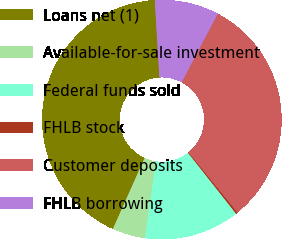Convert chart to OTSL. <chart><loc_0><loc_0><loc_500><loc_500><pie_chart><fcel>Loans net (1)<fcel>Available-for-sale investment<fcel>Federal funds sold<fcel>FHLB stock<fcel>Customer deposits<fcel>FHLB borrowing<nl><fcel>42.37%<fcel>4.45%<fcel>12.88%<fcel>0.24%<fcel>31.4%<fcel>8.66%<nl></chart> 